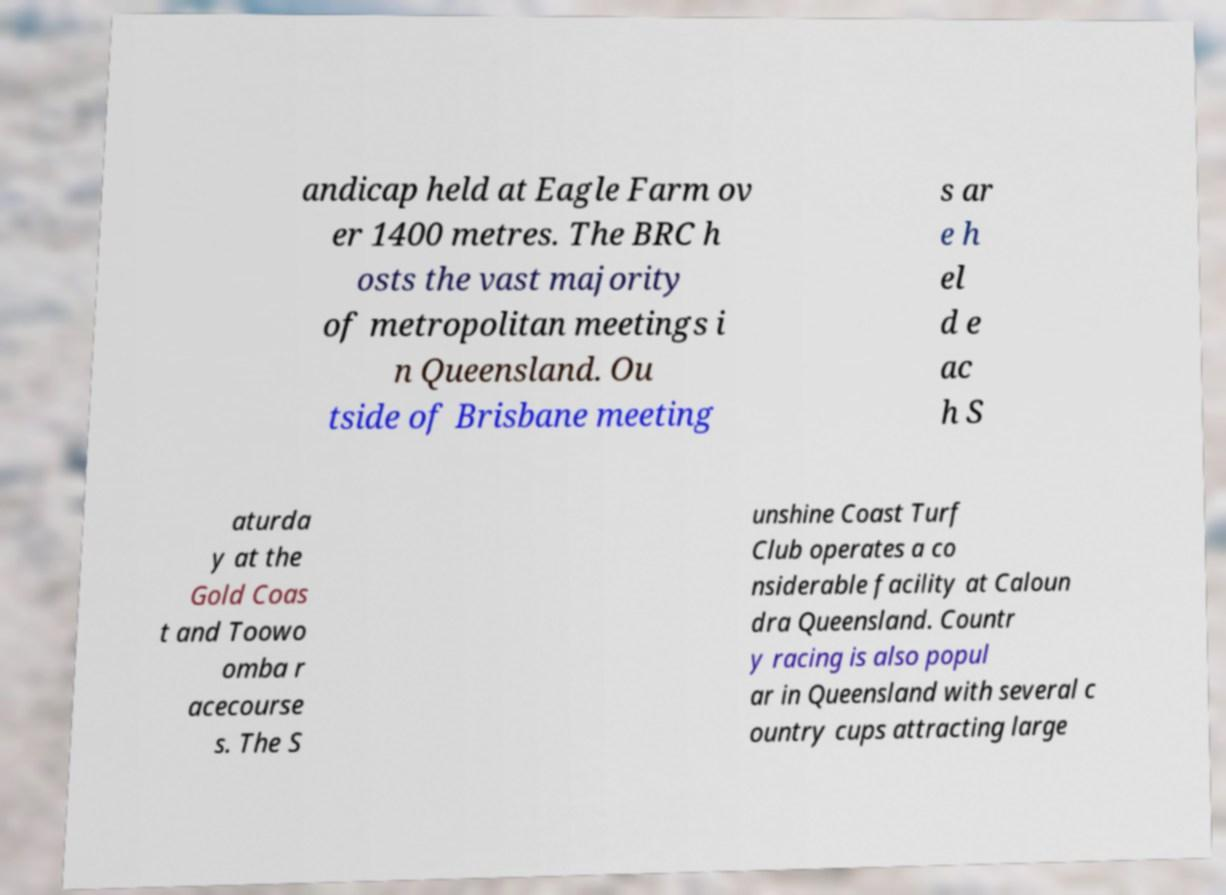Please identify and transcribe the text found in this image. andicap held at Eagle Farm ov er 1400 metres. The BRC h osts the vast majority of metropolitan meetings i n Queensland. Ou tside of Brisbane meeting s ar e h el d e ac h S aturda y at the Gold Coas t and Toowo omba r acecourse s. The S unshine Coast Turf Club operates a co nsiderable facility at Caloun dra Queensland. Countr y racing is also popul ar in Queensland with several c ountry cups attracting large 